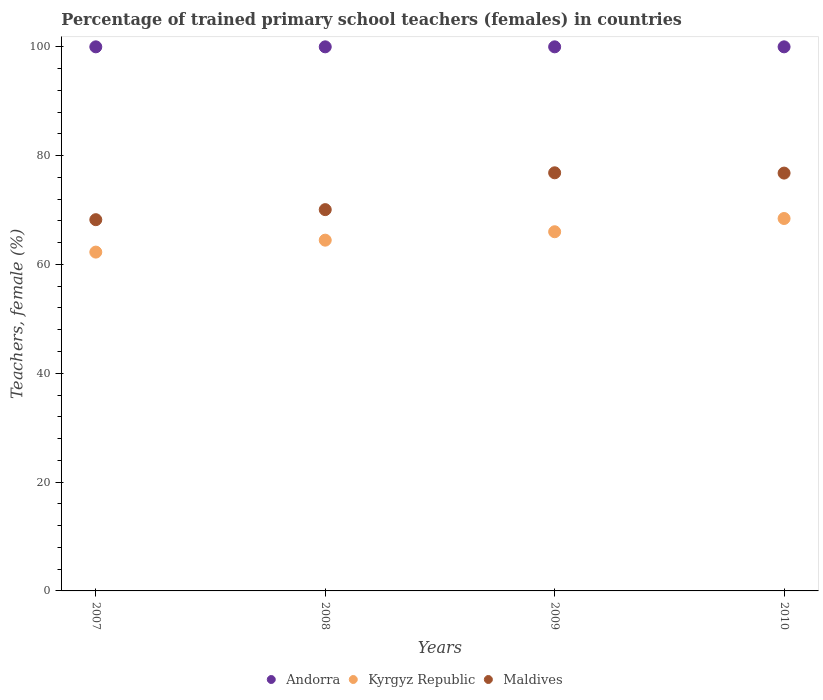Is the number of dotlines equal to the number of legend labels?
Give a very brief answer. Yes. What is the percentage of trained primary school teachers (females) in Kyrgyz Republic in 2008?
Ensure brevity in your answer.  64.47. Across all years, what is the maximum percentage of trained primary school teachers (females) in Maldives?
Provide a succinct answer. 76.85. In which year was the percentage of trained primary school teachers (females) in Maldives maximum?
Ensure brevity in your answer.  2009. In which year was the percentage of trained primary school teachers (females) in Andorra minimum?
Your response must be concise. 2007. What is the total percentage of trained primary school teachers (females) in Kyrgyz Republic in the graph?
Offer a very short reply. 261.2. What is the difference between the percentage of trained primary school teachers (females) in Andorra in 2007 and that in 2009?
Keep it short and to the point. 0. What is the difference between the percentage of trained primary school teachers (females) in Andorra in 2008 and the percentage of trained primary school teachers (females) in Maldives in 2007?
Ensure brevity in your answer.  31.77. What is the average percentage of trained primary school teachers (females) in Maldives per year?
Your response must be concise. 72.99. In the year 2009, what is the difference between the percentage of trained primary school teachers (females) in Kyrgyz Republic and percentage of trained primary school teachers (females) in Andorra?
Offer a terse response. -33.99. Is the percentage of trained primary school teachers (females) in Kyrgyz Republic in 2007 less than that in 2008?
Provide a short and direct response. Yes. What is the difference between the highest and the lowest percentage of trained primary school teachers (females) in Andorra?
Offer a terse response. 0. Is the sum of the percentage of trained primary school teachers (females) in Maldives in 2008 and 2009 greater than the maximum percentage of trained primary school teachers (females) in Andorra across all years?
Provide a succinct answer. Yes. Is it the case that in every year, the sum of the percentage of trained primary school teachers (females) in Kyrgyz Republic and percentage of trained primary school teachers (females) in Andorra  is greater than the percentage of trained primary school teachers (females) in Maldives?
Give a very brief answer. Yes. Does the percentage of trained primary school teachers (females) in Maldives monotonically increase over the years?
Give a very brief answer. No. Is the percentage of trained primary school teachers (females) in Kyrgyz Republic strictly less than the percentage of trained primary school teachers (females) in Andorra over the years?
Keep it short and to the point. Yes. How many dotlines are there?
Offer a terse response. 3. What is the difference between two consecutive major ticks on the Y-axis?
Offer a very short reply. 20. Are the values on the major ticks of Y-axis written in scientific E-notation?
Provide a short and direct response. No. Where does the legend appear in the graph?
Give a very brief answer. Bottom center. How many legend labels are there?
Provide a succinct answer. 3. How are the legend labels stacked?
Your response must be concise. Horizontal. What is the title of the graph?
Your response must be concise. Percentage of trained primary school teachers (females) in countries. Does "French Polynesia" appear as one of the legend labels in the graph?
Keep it short and to the point. No. What is the label or title of the Y-axis?
Provide a succinct answer. Teachers, female (%). What is the Teachers, female (%) of Kyrgyz Republic in 2007?
Your answer should be compact. 62.27. What is the Teachers, female (%) in Maldives in 2007?
Provide a short and direct response. 68.23. What is the Teachers, female (%) of Andorra in 2008?
Keep it short and to the point. 100. What is the Teachers, female (%) in Kyrgyz Republic in 2008?
Make the answer very short. 64.47. What is the Teachers, female (%) in Maldives in 2008?
Give a very brief answer. 70.08. What is the Teachers, female (%) of Kyrgyz Republic in 2009?
Ensure brevity in your answer.  66.01. What is the Teachers, female (%) in Maldives in 2009?
Your answer should be compact. 76.85. What is the Teachers, female (%) in Andorra in 2010?
Offer a terse response. 100. What is the Teachers, female (%) in Kyrgyz Republic in 2010?
Your answer should be compact. 68.45. What is the Teachers, female (%) of Maldives in 2010?
Provide a succinct answer. 76.8. Across all years, what is the maximum Teachers, female (%) of Kyrgyz Republic?
Provide a succinct answer. 68.45. Across all years, what is the maximum Teachers, female (%) of Maldives?
Keep it short and to the point. 76.85. Across all years, what is the minimum Teachers, female (%) of Andorra?
Offer a terse response. 100. Across all years, what is the minimum Teachers, female (%) in Kyrgyz Republic?
Offer a terse response. 62.27. Across all years, what is the minimum Teachers, female (%) of Maldives?
Provide a short and direct response. 68.23. What is the total Teachers, female (%) in Kyrgyz Republic in the graph?
Make the answer very short. 261.2. What is the total Teachers, female (%) of Maldives in the graph?
Give a very brief answer. 291.96. What is the difference between the Teachers, female (%) of Andorra in 2007 and that in 2008?
Give a very brief answer. 0. What is the difference between the Teachers, female (%) in Kyrgyz Republic in 2007 and that in 2008?
Offer a very short reply. -2.19. What is the difference between the Teachers, female (%) of Maldives in 2007 and that in 2008?
Ensure brevity in your answer.  -1.85. What is the difference between the Teachers, female (%) of Kyrgyz Republic in 2007 and that in 2009?
Keep it short and to the point. -3.74. What is the difference between the Teachers, female (%) in Maldives in 2007 and that in 2009?
Your response must be concise. -8.62. What is the difference between the Teachers, female (%) in Kyrgyz Republic in 2007 and that in 2010?
Give a very brief answer. -6.18. What is the difference between the Teachers, female (%) in Maldives in 2007 and that in 2010?
Provide a succinct answer. -8.56. What is the difference between the Teachers, female (%) in Andorra in 2008 and that in 2009?
Your response must be concise. 0. What is the difference between the Teachers, female (%) of Kyrgyz Republic in 2008 and that in 2009?
Your answer should be compact. -1.55. What is the difference between the Teachers, female (%) in Maldives in 2008 and that in 2009?
Give a very brief answer. -6.77. What is the difference between the Teachers, female (%) of Andorra in 2008 and that in 2010?
Ensure brevity in your answer.  0. What is the difference between the Teachers, female (%) of Kyrgyz Republic in 2008 and that in 2010?
Make the answer very short. -3.98. What is the difference between the Teachers, female (%) in Maldives in 2008 and that in 2010?
Offer a terse response. -6.71. What is the difference between the Teachers, female (%) in Andorra in 2009 and that in 2010?
Provide a succinct answer. 0. What is the difference between the Teachers, female (%) of Kyrgyz Republic in 2009 and that in 2010?
Your answer should be very brief. -2.43. What is the difference between the Teachers, female (%) in Maldives in 2009 and that in 2010?
Make the answer very short. 0.05. What is the difference between the Teachers, female (%) of Andorra in 2007 and the Teachers, female (%) of Kyrgyz Republic in 2008?
Provide a short and direct response. 35.53. What is the difference between the Teachers, female (%) of Andorra in 2007 and the Teachers, female (%) of Maldives in 2008?
Your response must be concise. 29.92. What is the difference between the Teachers, female (%) in Kyrgyz Republic in 2007 and the Teachers, female (%) in Maldives in 2008?
Your answer should be very brief. -7.81. What is the difference between the Teachers, female (%) of Andorra in 2007 and the Teachers, female (%) of Kyrgyz Republic in 2009?
Your response must be concise. 33.99. What is the difference between the Teachers, female (%) in Andorra in 2007 and the Teachers, female (%) in Maldives in 2009?
Provide a short and direct response. 23.15. What is the difference between the Teachers, female (%) of Kyrgyz Republic in 2007 and the Teachers, female (%) of Maldives in 2009?
Your answer should be compact. -14.58. What is the difference between the Teachers, female (%) of Andorra in 2007 and the Teachers, female (%) of Kyrgyz Republic in 2010?
Offer a very short reply. 31.55. What is the difference between the Teachers, female (%) in Andorra in 2007 and the Teachers, female (%) in Maldives in 2010?
Your answer should be compact. 23.2. What is the difference between the Teachers, female (%) in Kyrgyz Republic in 2007 and the Teachers, female (%) in Maldives in 2010?
Give a very brief answer. -14.52. What is the difference between the Teachers, female (%) of Andorra in 2008 and the Teachers, female (%) of Kyrgyz Republic in 2009?
Provide a short and direct response. 33.99. What is the difference between the Teachers, female (%) of Andorra in 2008 and the Teachers, female (%) of Maldives in 2009?
Your answer should be compact. 23.15. What is the difference between the Teachers, female (%) in Kyrgyz Republic in 2008 and the Teachers, female (%) in Maldives in 2009?
Keep it short and to the point. -12.38. What is the difference between the Teachers, female (%) of Andorra in 2008 and the Teachers, female (%) of Kyrgyz Republic in 2010?
Ensure brevity in your answer.  31.55. What is the difference between the Teachers, female (%) of Andorra in 2008 and the Teachers, female (%) of Maldives in 2010?
Offer a terse response. 23.2. What is the difference between the Teachers, female (%) in Kyrgyz Republic in 2008 and the Teachers, female (%) in Maldives in 2010?
Your answer should be compact. -12.33. What is the difference between the Teachers, female (%) of Andorra in 2009 and the Teachers, female (%) of Kyrgyz Republic in 2010?
Offer a very short reply. 31.55. What is the difference between the Teachers, female (%) of Andorra in 2009 and the Teachers, female (%) of Maldives in 2010?
Ensure brevity in your answer.  23.2. What is the difference between the Teachers, female (%) of Kyrgyz Republic in 2009 and the Teachers, female (%) of Maldives in 2010?
Make the answer very short. -10.78. What is the average Teachers, female (%) of Kyrgyz Republic per year?
Provide a short and direct response. 65.3. What is the average Teachers, female (%) of Maldives per year?
Your answer should be very brief. 72.99. In the year 2007, what is the difference between the Teachers, female (%) in Andorra and Teachers, female (%) in Kyrgyz Republic?
Your response must be concise. 37.73. In the year 2007, what is the difference between the Teachers, female (%) of Andorra and Teachers, female (%) of Maldives?
Provide a succinct answer. 31.77. In the year 2007, what is the difference between the Teachers, female (%) in Kyrgyz Republic and Teachers, female (%) in Maldives?
Make the answer very short. -5.96. In the year 2008, what is the difference between the Teachers, female (%) in Andorra and Teachers, female (%) in Kyrgyz Republic?
Provide a short and direct response. 35.53. In the year 2008, what is the difference between the Teachers, female (%) in Andorra and Teachers, female (%) in Maldives?
Make the answer very short. 29.92. In the year 2008, what is the difference between the Teachers, female (%) of Kyrgyz Republic and Teachers, female (%) of Maldives?
Your response must be concise. -5.61. In the year 2009, what is the difference between the Teachers, female (%) of Andorra and Teachers, female (%) of Kyrgyz Republic?
Offer a terse response. 33.99. In the year 2009, what is the difference between the Teachers, female (%) in Andorra and Teachers, female (%) in Maldives?
Your answer should be compact. 23.15. In the year 2009, what is the difference between the Teachers, female (%) of Kyrgyz Republic and Teachers, female (%) of Maldives?
Ensure brevity in your answer.  -10.83. In the year 2010, what is the difference between the Teachers, female (%) of Andorra and Teachers, female (%) of Kyrgyz Republic?
Provide a succinct answer. 31.55. In the year 2010, what is the difference between the Teachers, female (%) of Andorra and Teachers, female (%) of Maldives?
Your response must be concise. 23.2. In the year 2010, what is the difference between the Teachers, female (%) in Kyrgyz Republic and Teachers, female (%) in Maldives?
Your answer should be compact. -8.35. What is the ratio of the Teachers, female (%) of Maldives in 2007 to that in 2008?
Offer a terse response. 0.97. What is the ratio of the Teachers, female (%) of Kyrgyz Republic in 2007 to that in 2009?
Offer a very short reply. 0.94. What is the ratio of the Teachers, female (%) of Maldives in 2007 to that in 2009?
Offer a terse response. 0.89. What is the ratio of the Teachers, female (%) in Kyrgyz Republic in 2007 to that in 2010?
Offer a terse response. 0.91. What is the ratio of the Teachers, female (%) of Maldives in 2007 to that in 2010?
Your response must be concise. 0.89. What is the ratio of the Teachers, female (%) of Kyrgyz Republic in 2008 to that in 2009?
Offer a very short reply. 0.98. What is the ratio of the Teachers, female (%) in Maldives in 2008 to that in 2009?
Your response must be concise. 0.91. What is the ratio of the Teachers, female (%) in Andorra in 2008 to that in 2010?
Offer a very short reply. 1. What is the ratio of the Teachers, female (%) in Kyrgyz Republic in 2008 to that in 2010?
Keep it short and to the point. 0.94. What is the ratio of the Teachers, female (%) of Maldives in 2008 to that in 2010?
Ensure brevity in your answer.  0.91. What is the ratio of the Teachers, female (%) of Kyrgyz Republic in 2009 to that in 2010?
Your answer should be compact. 0.96. What is the difference between the highest and the second highest Teachers, female (%) of Kyrgyz Republic?
Provide a short and direct response. 2.43. What is the difference between the highest and the second highest Teachers, female (%) of Maldives?
Give a very brief answer. 0.05. What is the difference between the highest and the lowest Teachers, female (%) of Andorra?
Make the answer very short. 0. What is the difference between the highest and the lowest Teachers, female (%) in Kyrgyz Republic?
Your answer should be very brief. 6.18. What is the difference between the highest and the lowest Teachers, female (%) of Maldives?
Your response must be concise. 8.62. 